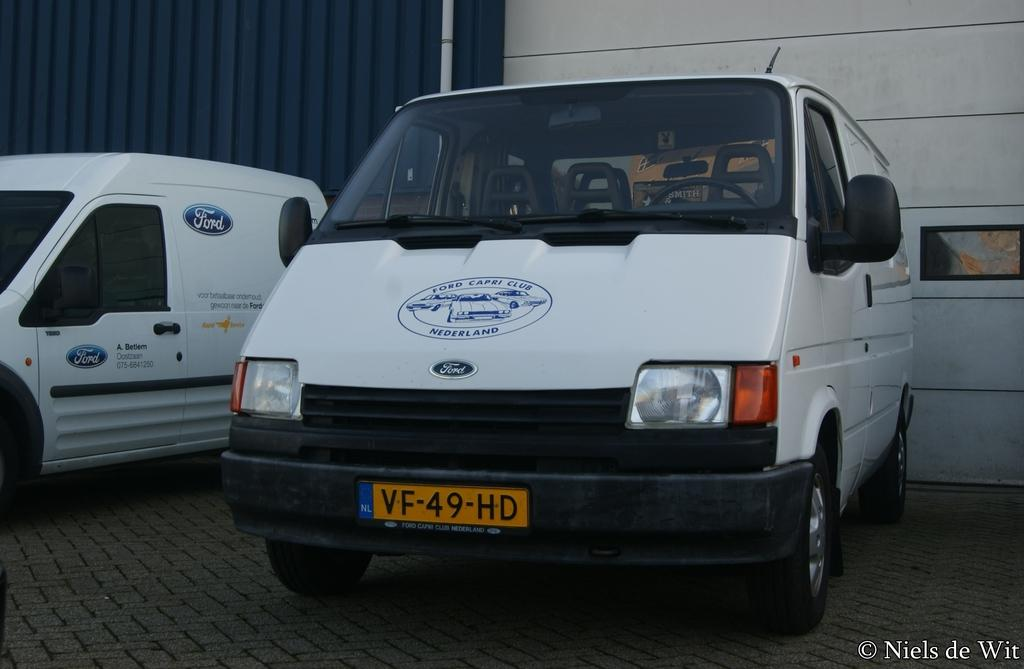<image>
Offer a succinct explanation of the picture presented. A white Ford van with a blue logo for the Ford Capri Club on its hood 